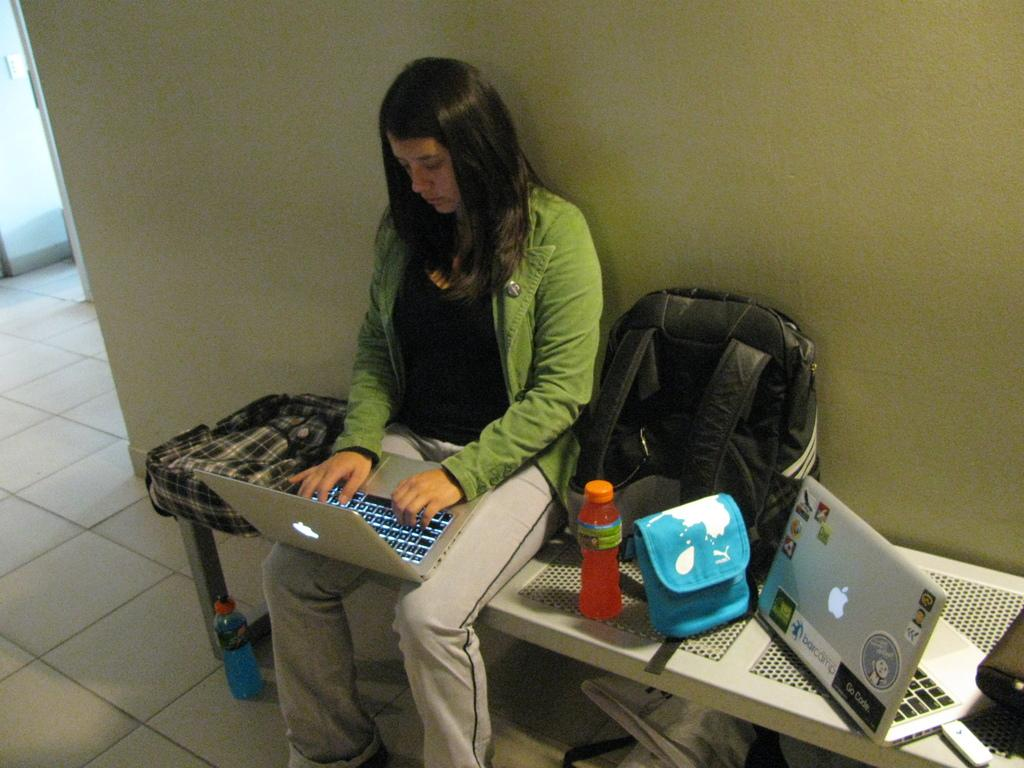What is the woman doing on the bench in the image? The woman is operating a MacBook on the bench. What else can be seen on the bench besides the woman and her laptop? There is a bag and a water bottle on the bench. What type of bag is on the bench? The provided facts do not specify the type of bag. Can you describe the laptop the woman is using? The laptop is a MacBook, as mentioned in the facts. How many birds are flying over the woman's head in the image? There are no birds visible in the image. What type of laborer is working on the laptop with the woman? There is no laborer present in the image; the woman is the only person operating the laptop. 